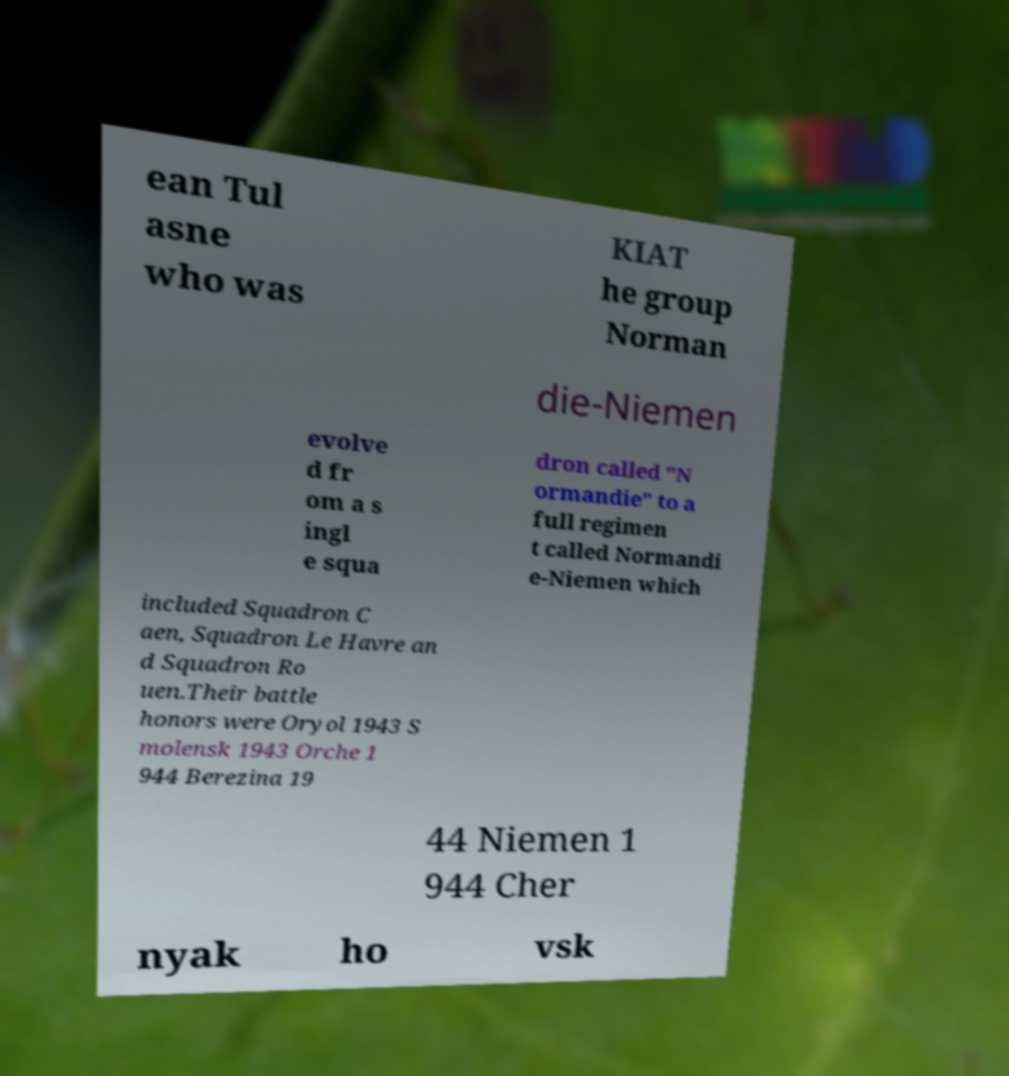What messages or text are displayed in this image? I need them in a readable, typed format. ean Tul asne who was KIAT he group Norman die-Niemen evolve d fr om a s ingl e squa dron called "N ormandie" to a full regimen t called Normandi e-Niemen which included Squadron C aen, Squadron Le Havre an d Squadron Ro uen.Their battle honors were Oryol 1943 S molensk 1943 Orche 1 944 Berezina 19 44 Niemen 1 944 Cher nyak ho vsk 